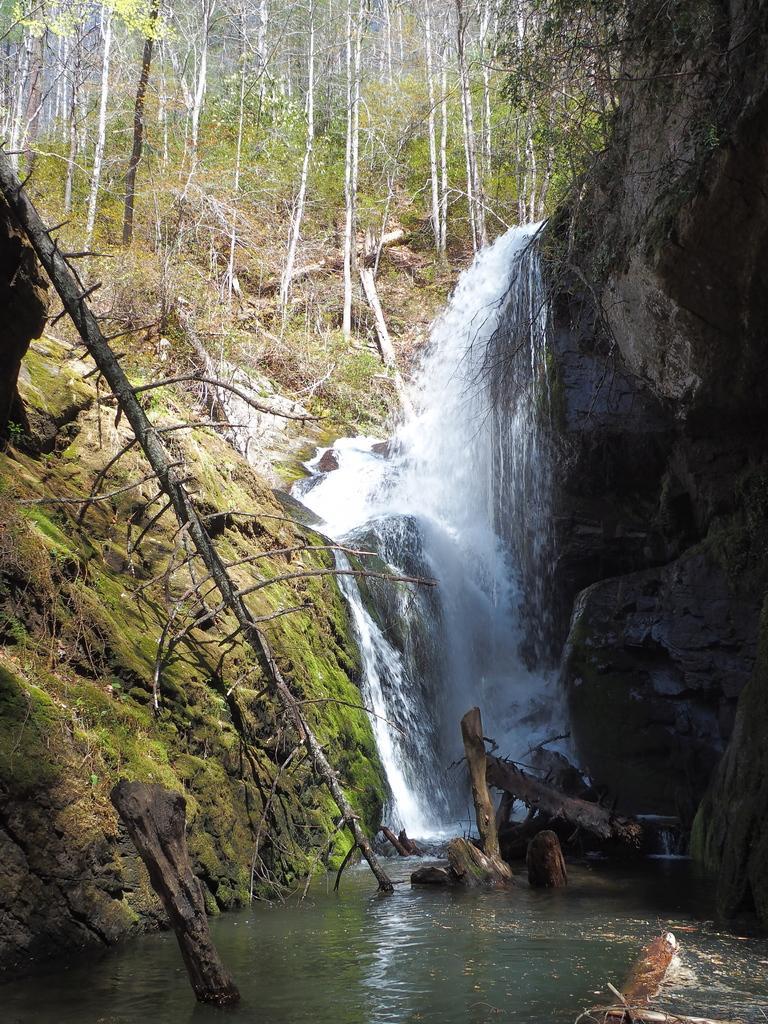Describe this image in one or two sentences. In this image I can see the water. There are the branches of the tree in the water. To the side of the water I can see the rock and the mountain. I can see the water flowing from the rock. In the background I can see many trees. 